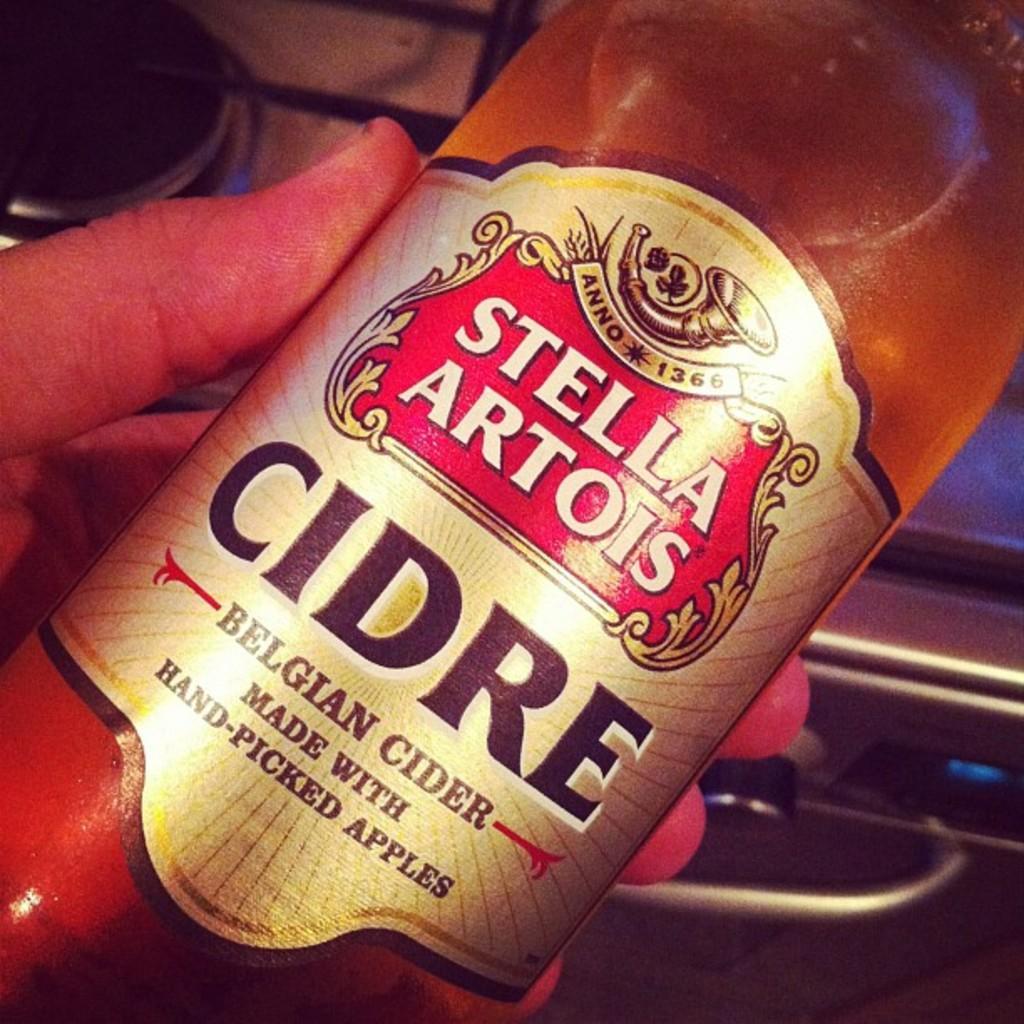Please provide a concise description of this image. In this image, we can see human hand with bottle. Here there is a sticker on it. Background we can see stove, handle and digital screen. 